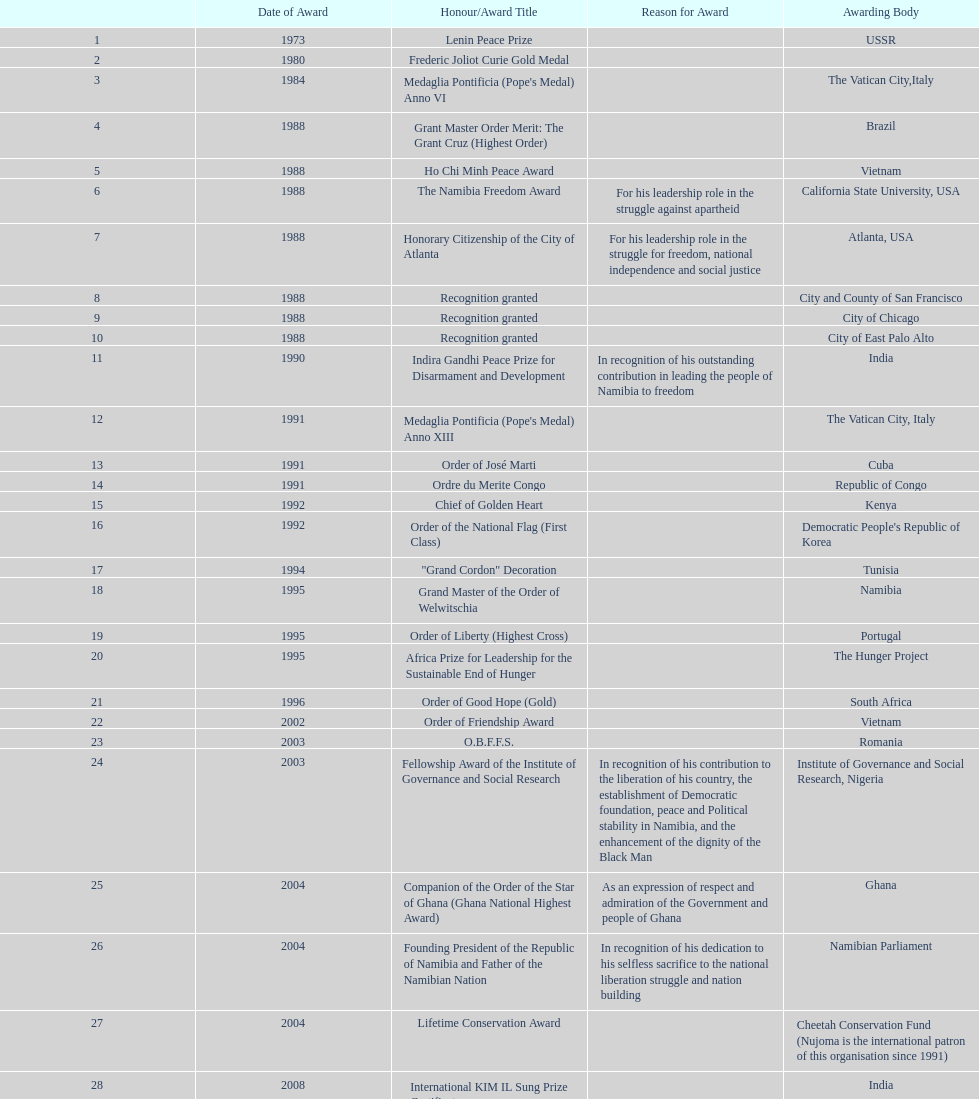What is the last honors/award title listed on this chart? Sir Seretse Khama SADC Meda. 